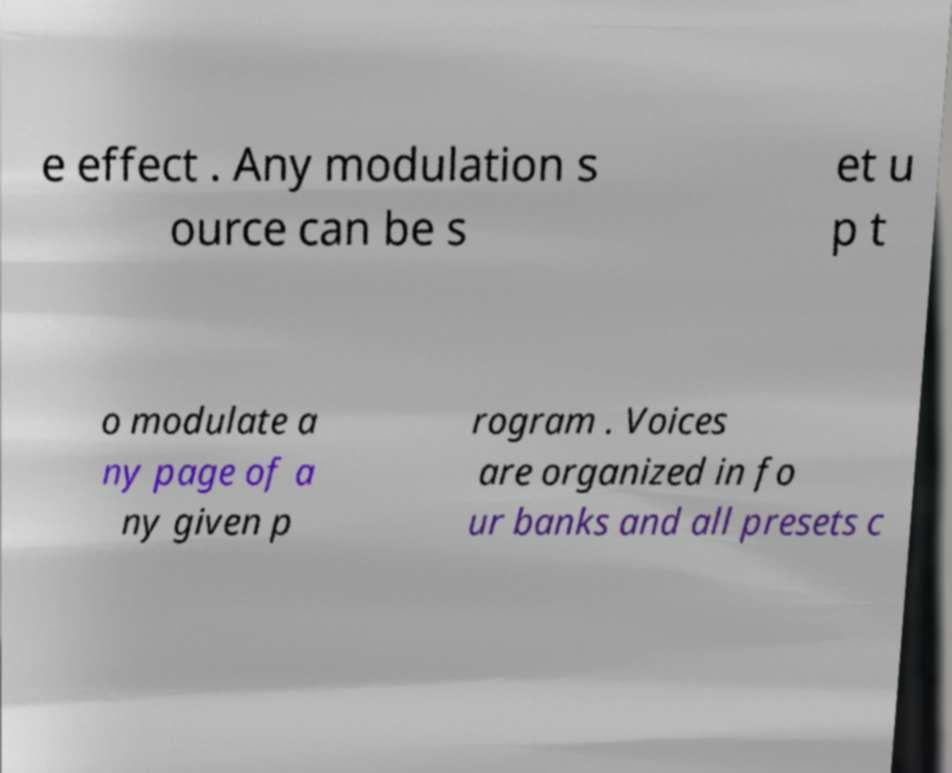Please read and relay the text visible in this image. What does it say? e effect . Any modulation s ource can be s et u p t o modulate a ny page of a ny given p rogram . Voices are organized in fo ur banks and all presets c 